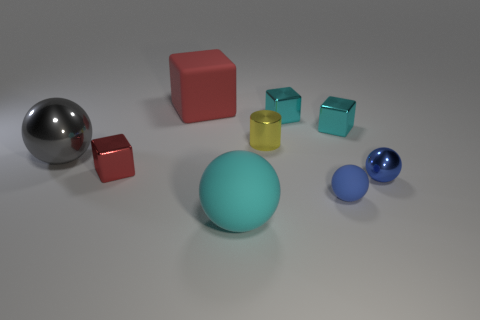Subtract all metal cubes. How many cubes are left? 1 Subtract all red blocks. How many blue spheres are left? 2 Add 1 tiny cyan matte blocks. How many objects exist? 10 Subtract 2 balls. How many balls are left? 2 Subtract all cyan spheres. How many spheres are left? 3 Subtract all cylinders. How many objects are left? 8 Subtract all brown balls. Subtract all gray blocks. How many balls are left? 4 Subtract all big purple rubber cubes. Subtract all blue metallic objects. How many objects are left? 8 Add 3 small blue objects. How many small blue objects are left? 5 Add 8 big cyan objects. How many big cyan objects exist? 9 